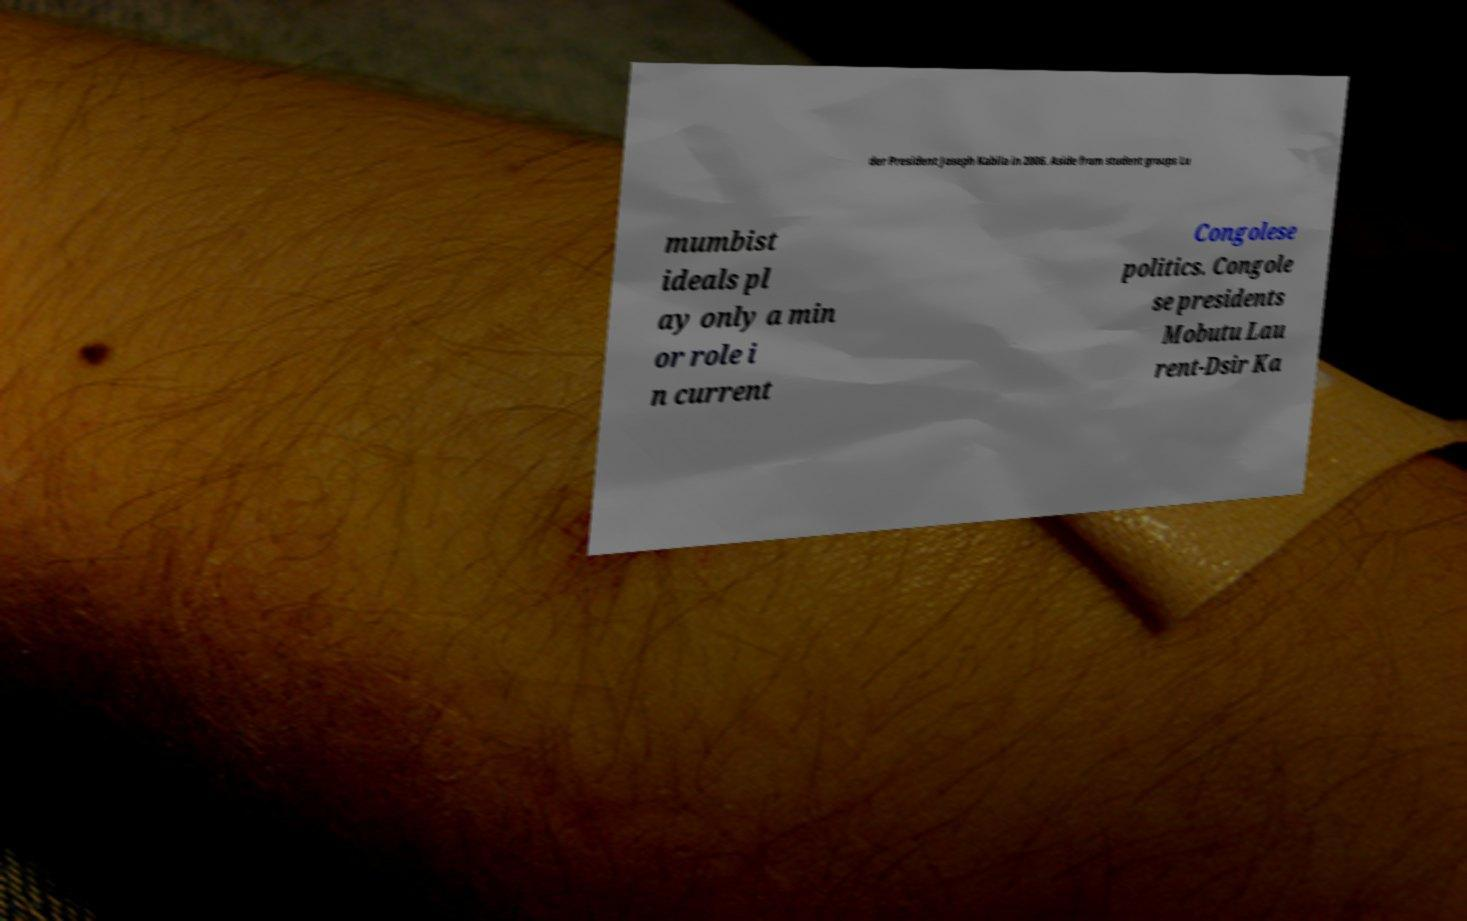There's text embedded in this image that I need extracted. Can you transcribe it verbatim? der President Joseph Kabila in 2006. Aside from student groups Lu mumbist ideals pl ay only a min or role i n current Congolese politics. Congole se presidents Mobutu Lau rent-Dsir Ka 